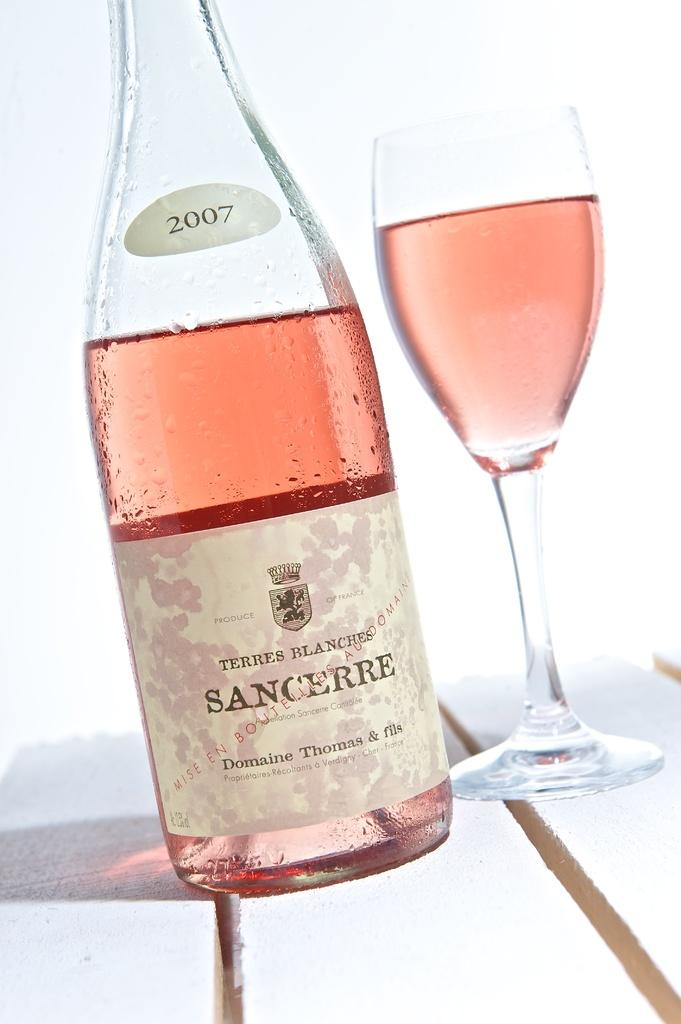What color is the beer bottle in the image? The beer bottle in the image is pink. Where is the beer bottle located? The beer bottle is on a table. What else is on the table in the image? There is a glass on the table. How is the glass positioned in relation to the beer bottle? The glass is on top of the beer bottle. What type of label is on the beer bottle? The beer bottle has a Sancheere label on it. What advice does the mailbox give to the men in the image? There is no mailbox or men present in the image, so no advice can be given. 